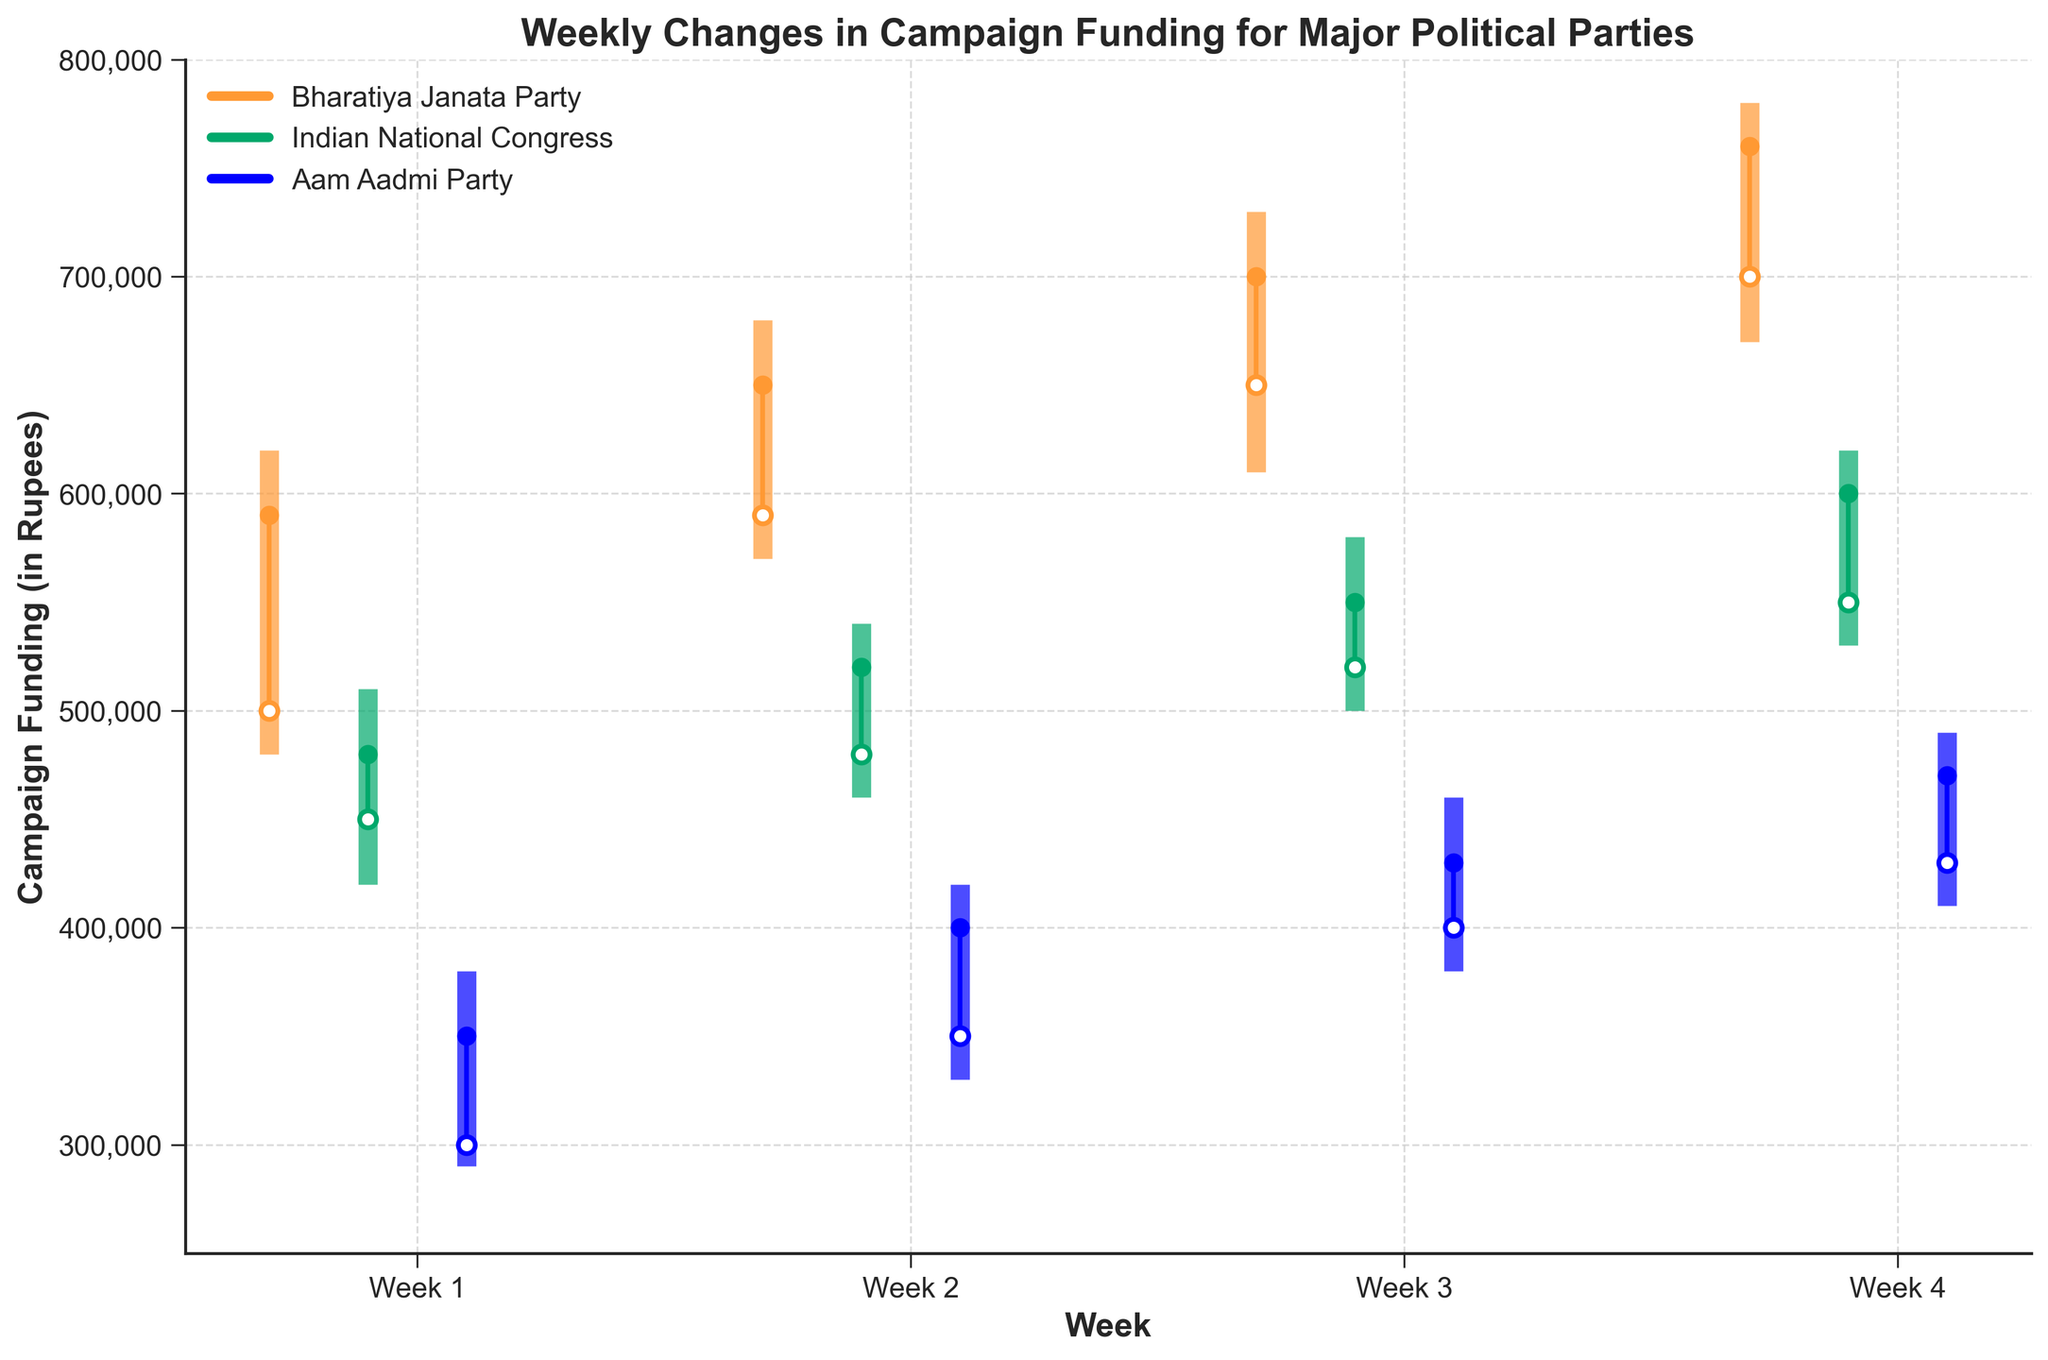What's the title of the chart? The title of the chart is located at the top and provides an overview of the content depicted in the chart.
Answer: Weekly Changes in Campaign Funding for Major Political Parties How many weeks of data are presented in the chart? The chart's x-axis is labeled with 'Week' and shows labels for each time period. By counting these labels, we can determine the number of weeks.
Answer: 4 What is the highest funding amount reached by the Bharatiya Janata Party, and in which week did it occur? Look for the highest point in the 'High' column for the Bharatiya Janata Party and note the corresponding week.
Answer: 780,000 in Week 4 Which political party had the lowest closing amount in Week 2? To find the lowest closing amount, check the 'Close' values for each party in Week 2 and identify the smallest one.
Answer: Aam Aadmi Party Between Week 1 and Week 3, which party showed the greatest increase in closing amounts? Calculate the difference in the 'Close' amounts for each party from Week 1 to Week 3. The party with the highest positive difference has the greatest increase.
Answer: Bharatiya Janata Party In which week did the Indian National Congress have the most significant fluctuation in funding, measured by the difference between High and Low amounts? Calculate the difference between the 'High' and 'Low' amounts for each week for the Indian National Congress and identify the week with the highest difference.
Answer: Week 4 From Week 3 to Week 4, how much did the closing amount for the Aam Aadmi Party increase? Subtract the 'Close' amount in Week 3 from the 'Close' amount in Week 4 for the Aam Aadmi Party.
Answer: 40,000 Which party had a higher opening value in Week 2, and by how much? Compare the 'Open' values of the Bharatiya Janata Party and the Indian National Congress in Week 2 and calculate the difference.
Answer: Bharatiya Janata Party by 110,000 How did the closing amount for the Indian National Congress change from Week 1 to Week 4? Subtract the 'Close' amount in Week 1 from the 'Close' amount in Week 4 for the Indian National Congress.
Answer: Increased by 120,000 